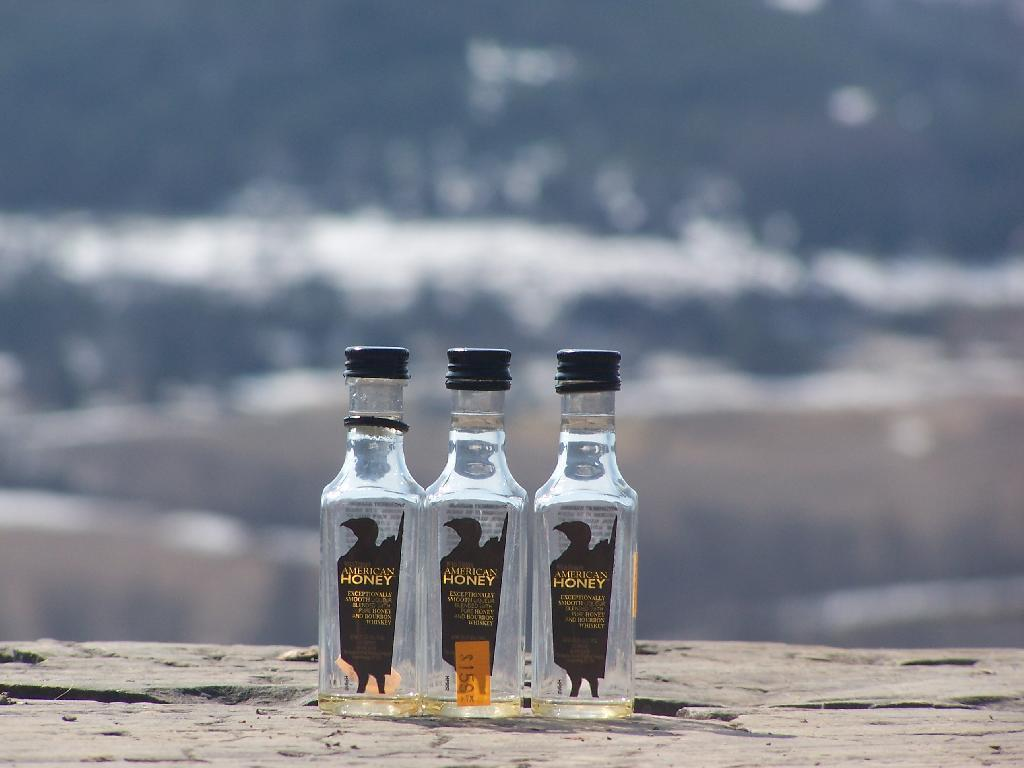Provide a one-sentence caption for the provided image. The empty bottles of American honey with lids on. 